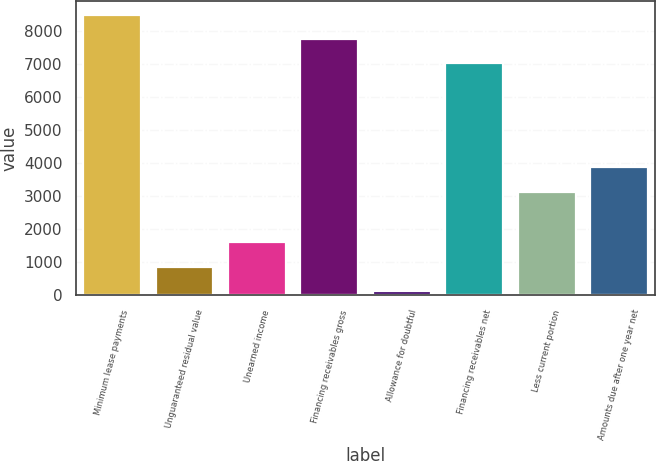<chart> <loc_0><loc_0><loc_500><loc_500><bar_chart><fcel>Minimum lease payments<fcel>Unguaranteed residual value<fcel>Unearned income<fcel>Financing receivables gross<fcel>Allowance for doubtful<fcel>Financing receivables net<fcel>Less current portion<fcel>Amounts due after one year net<nl><fcel>8496.8<fcel>868.4<fcel>1605.8<fcel>7759.4<fcel>131<fcel>7022<fcel>3144<fcel>3881.4<nl></chart> 